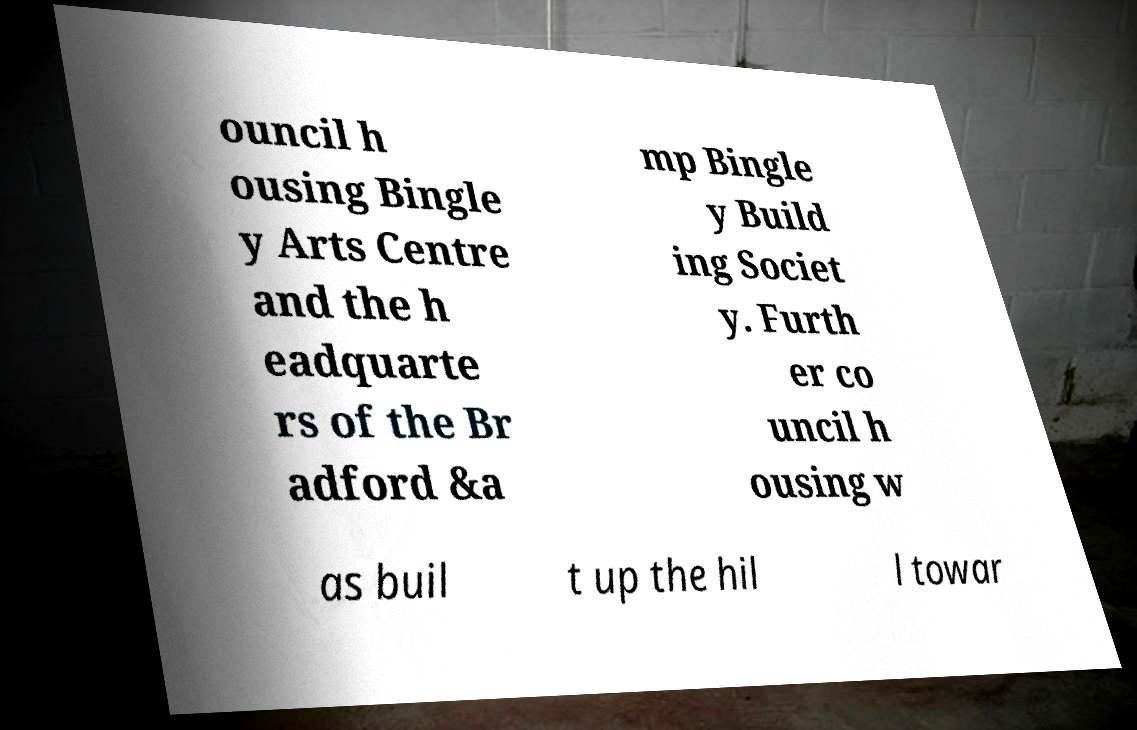Can you read and provide the text displayed in the image?This photo seems to have some interesting text. Can you extract and type it out for me? ouncil h ousing Bingle y Arts Centre and the h eadquarte rs of the Br adford &a mp Bingle y Build ing Societ y. Furth er co uncil h ousing w as buil t up the hil l towar 